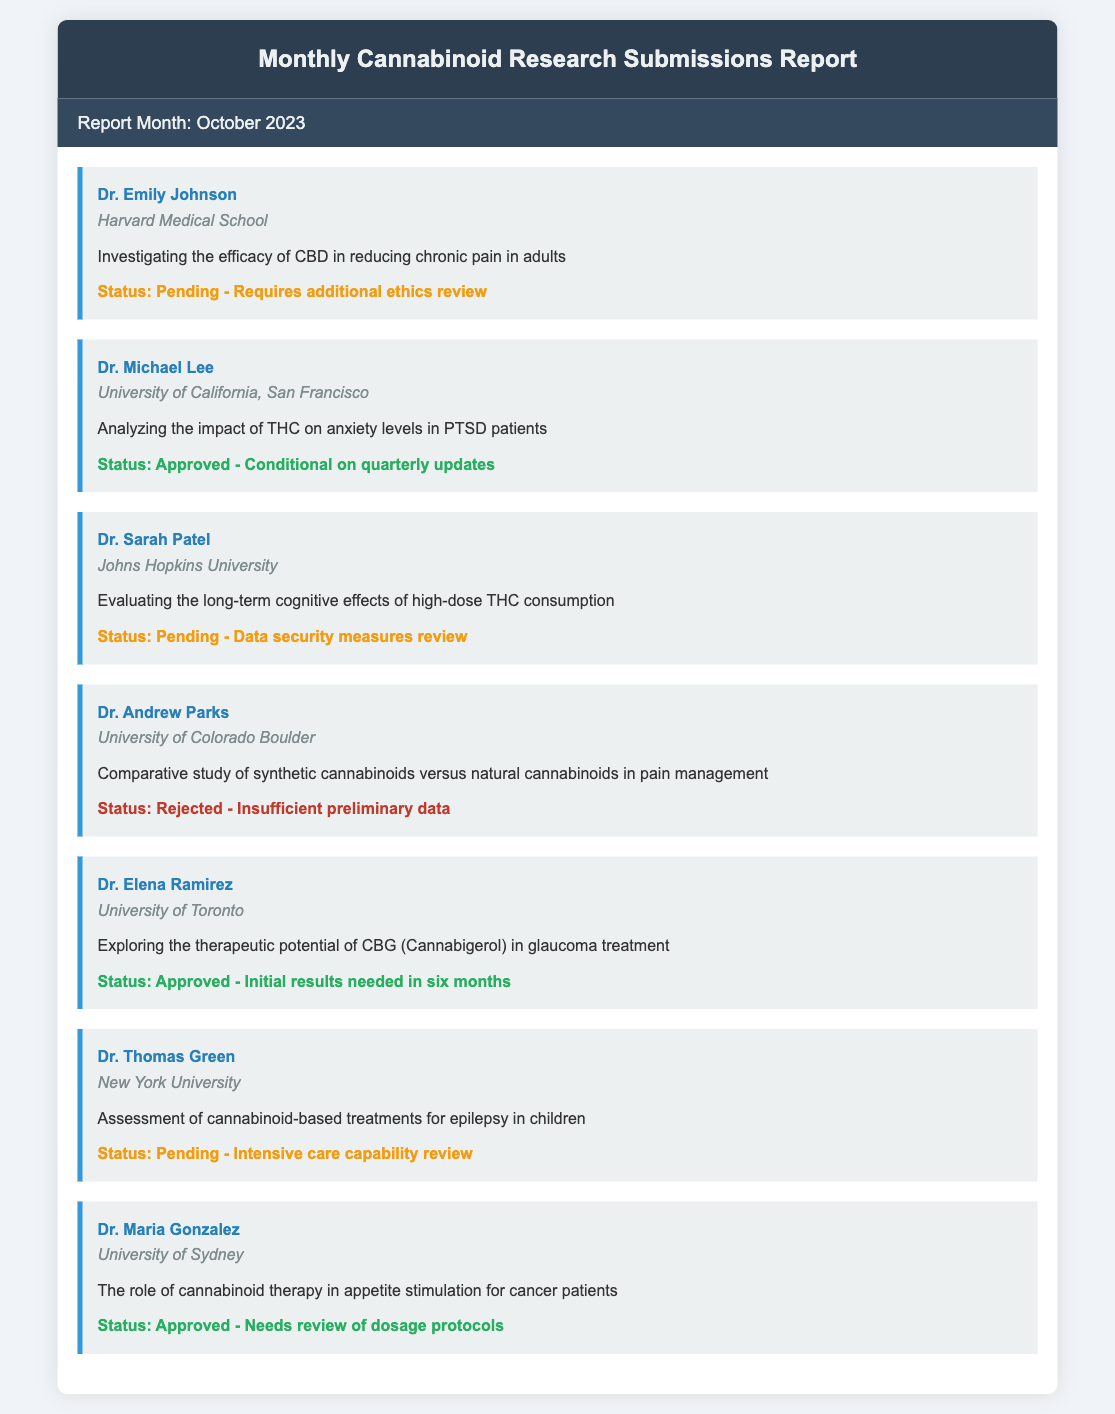What is the report month? The report month is explicitly stated at the top of the submissions section.
Answer: October 2023 How many studies have been submitted by Dr. Emily Johnson? The document lists several submissions, and Dr. Emily Johnson's is one of them.
Answer: One What is the status of Dr. Michael Lee's submission? Dr. Michael Lee's submission is noted with a specific status below his name.
Answer: Approved - Conditional on quarterly updates Which institution is Dr. Elena Ramirez associated with? The institution for Dr. Elena Ramirez is mentioned directly beneath her name.
Answer: University of Toronto What is the purpose of Dr. Thomas Green's study? The purpose of Dr. Thomas Green's study is detailed in the document following his name and institution.
Answer: Assessment of cannabinoid-based treatments for epilepsy in children How many submissions are pending approval? The status of each submission is provided, and pending submissions can be counted.
Answer: Three What type of cannabinoid is being researched by Dr. Elena Ramirez? The document specifies the type of cannabinoid in Dr. Elena Ramirez's research purpose.
Answer: CBG (Cannabigerol) What was the reason for the rejection of Dr. Andrew Parks' submission? The rejection reason is given in the status section of Dr. Andrew Parks' submission.
Answer: Insufficient preliminary data Which researcher is focused on THC and anxiety levels? The researcher studying THC's impact on anxiety levels is listed in the submissions section.
Answer: Dr. Michael Lee 